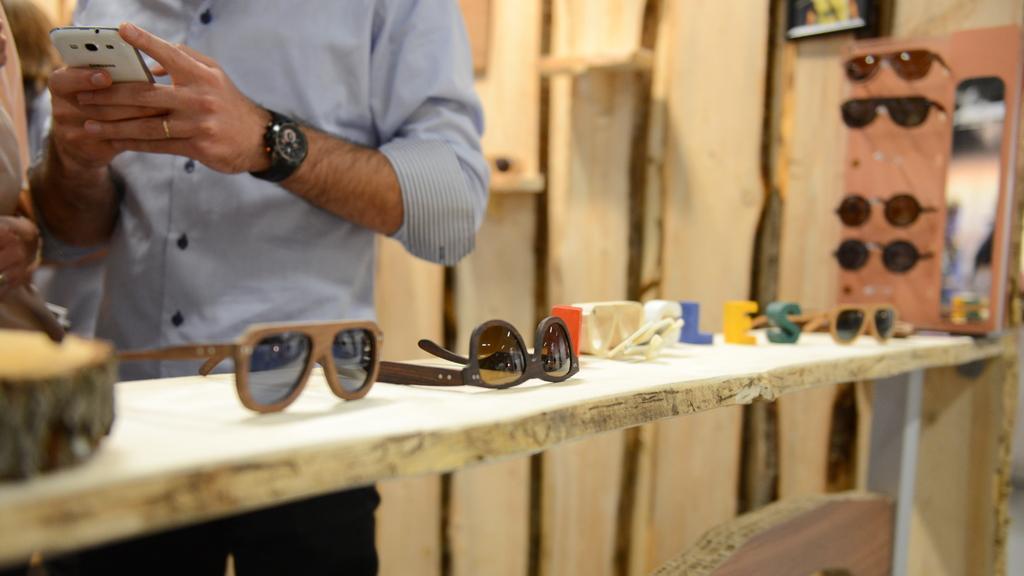Please provide a concise description of this image. There is a man standing and holding mobile, in front of him we can see goggles, goggles with stand and objects on the table. In the background it is blurry and there is a person standing and we can see wooden planks. 